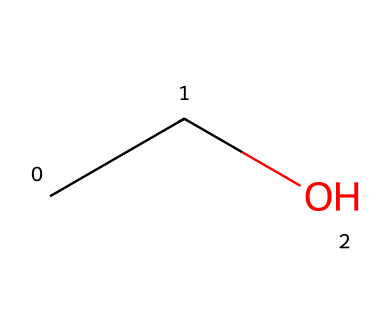What is the molecular formula of this chemical? The chemical structure represented by the SMILES CC(O) indicates two carbon atoms, six hydrogen atoms, and one oxygen atom. Thus, the molecular formula can be derived as C2H6O.
Answer: C2H6O How many hydrogen atoms are present in this compound? Analyzing the chemical structure from the SMILES, we find that there are six hydrogen atoms attached to the two carbon atoms. Therefore, the total number of hydrogen atoms is six.
Answer: 6 What type of functional group is present in ethanol? The presence of a hydroxyl group (-OH) in the structure indicates that this compound has an alcohol functional group. This can be seen from the last part of the SMILES where oxygen is connected to a carbon with a hydrogen.
Answer: alcohol Is ethanol a primary, secondary, or tertiary alcohol? In the structure of ethanol, the -OH group is attached to a carbon atom that is connected to only one other carbon and three hydrogen atoms, which defines it as a primary alcohol. Therefore, ethanol is classified as a primary alcohol.
Answer: primary What is the role of ethanol in wine production? Ethanol acts as the primary alcohol produced during fermentation, which is crucial for converting sugars from grapes into alcohol, thereby defining its importance in wine production.
Answer: fermentation How many carbon atoms does ethanol have? From the SMILES representation CC(O), we can see that there are two carbon atoms indicated by the two "C" characters at the beginning of the SMILES. Therefore, ethanol contains two carbon atoms.
Answer: 2 